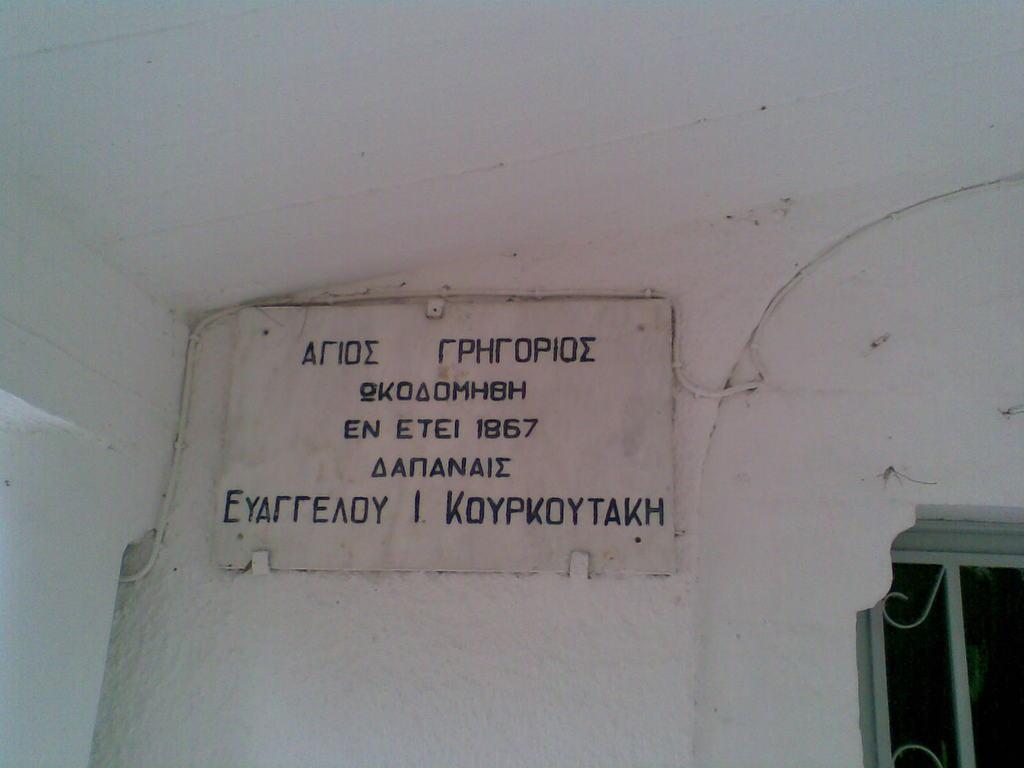How would you summarize this image in a sentence or two? Here we can see a name board with some text on the white wall. Right side of the image, we can see a grill. 